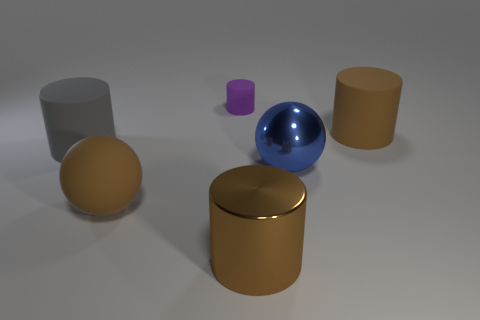Is the shape of the big brown metallic thing the same as the purple thing?
Your answer should be compact. Yes. What number of other objects are there of the same shape as the gray rubber thing?
Offer a very short reply. 3. What color is the metallic cylinder that is the same size as the blue object?
Ensure brevity in your answer.  Brown. Are there an equal number of large brown metallic cylinders that are on the left side of the big gray cylinder and yellow things?
Your answer should be compact. Yes. What is the shape of the rubber thing that is both to the left of the big blue thing and behind the gray object?
Ensure brevity in your answer.  Cylinder. Do the matte ball and the brown rubber cylinder have the same size?
Give a very brief answer. Yes. Is there a small cylinder made of the same material as the big gray cylinder?
Your response must be concise. Yes. What size is the rubber cylinder that is the same color as the rubber ball?
Keep it short and to the point. Large. How many large objects are in front of the blue shiny sphere and right of the purple cylinder?
Offer a very short reply. 1. There is a tiny thing behind the big matte ball; what is its material?
Ensure brevity in your answer.  Rubber. 